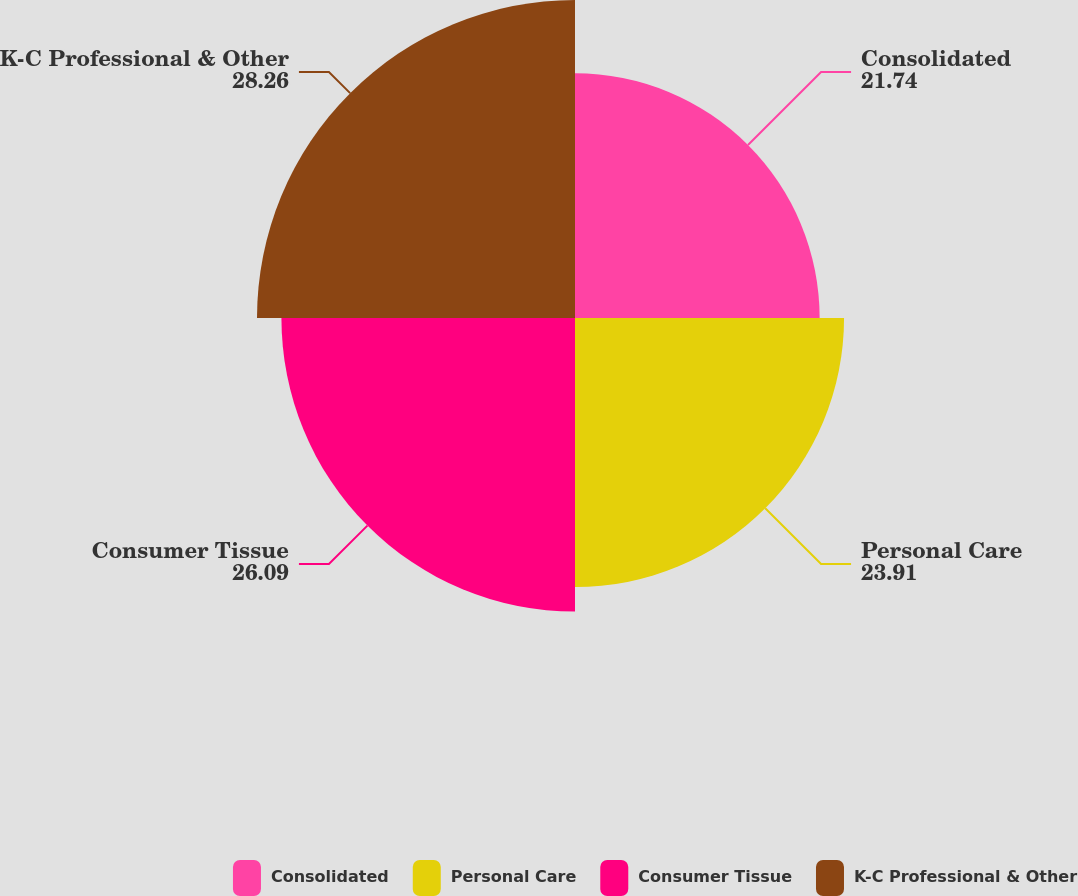<chart> <loc_0><loc_0><loc_500><loc_500><pie_chart><fcel>Consolidated<fcel>Personal Care<fcel>Consumer Tissue<fcel>K-C Professional & Other<nl><fcel>21.74%<fcel>23.91%<fcel>26.09%<fcel>28.26%<nl></chart> 